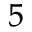<formula> <loc_0><loc_0><loc_500><loc_500>^ { 5 }</formula> 